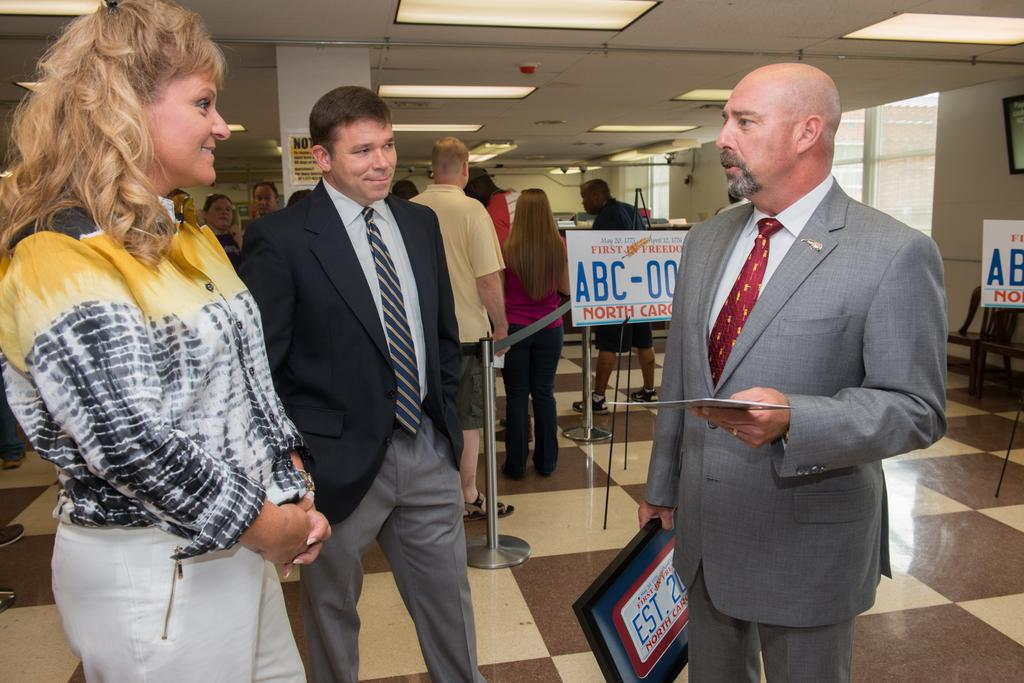How many people are in the image? There is a group of people in the image, but the exact number cannot be determined from the provided facts. What can be seen in the background of the image? In the background of the image, there are boards, metal rods, and lights. Where is the frame located in the image? The frame is on the wall on the right side of the image. What type of credit card is being used by the people in the image? There is no mention of credit cards or any financial transactions in the image, so it cannot be determined from the provided facts. What does the image smell like? The image is a visual representation and does not have a smell. 